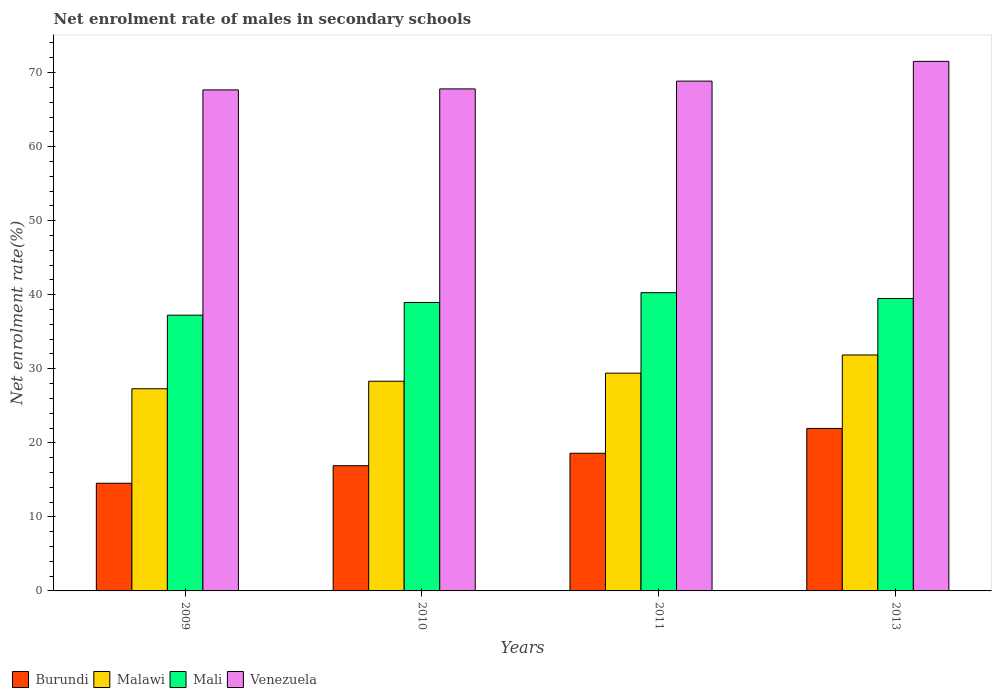How many different coloured bars are there?
Provide a succinct answer. 4. How many groups of bars are there?
Your answer should be very brief. 4. Are the number of bars per tick equal to the number of legend labels?
Keep it short and to the point. Yes. Are the number of bars on each tick of the X-axis equal?
Provide a succinct answer. Yes. How many bars are there on the 4th tick from the left?
Ensure brevity in your answer.  4. How many bars are there on the 2nd tick from the right?
Your answer should be very brief. 4. What is the label of the 3rd group of bars from the left?
Your answer should be very brief. 2011. What is the net enrolment rate of males in secondary schools in Malawi in 2011?
Offer a very short reply. 29.41. Across all years, what is the maximum net enrolment rate of males in secondary schools in Venezuela?
Provide a short and direct response. 71.52. Across all years, what is the minimum net enrolment rate of males in secondary schools in Malawi?
Offer a terse response. 27.3. In which year was the net enrolment rate of males in secondary schools in Burundi maximum?
Your answer should be very brief. 2013. What is the total net enrolment rate of males in secondary schools in Malawi in the graph?
Provide a succinct answer. 116.9. What is the difference between the net enrolment rate of males in secondary schools in Burundi in 2009 and that in 2010?
Your answer should be compact. -2.37. What is the difference between the net enrolment rate of males in secondary schools in Malawi in 2010 and the net enrolment rate of males in secondary schools in Burundi in 2009?
Give a very brief answer. 13.78. What is the average net enrolment rate of males in secondary schools in Malawi per year?
Provide a succinct answer. 29.22. In the year 2011, what is the difference between the net enrolment rate of males in secondary schools in Burundi and net enrolment rate of males in secondary schools in Malawi?
Your answer should be very brief. -10.82. What is the ratio of the net enrolment rate of males in secondary schools in Burundi in 2010 to that in 2013?
Your answer should be compact. 0.77. Is the difference between the net enrolment rate of males in secondary schools in Burundi in 2009 and 2010 greater than the difference between the net enrolment rate of males in secondary schools in Malawi in 2009 and 2010?
Provide a succinct answer. No. What is the difference between the highest and the second highest net enrolment rate of males in secondary schools in Malawi?
Your answer should be compact. 2.46. What is the difference between the highest and the lowest net enrolment rate of males in secondary schools in Malawi?
Your answer should be very brief. 4.56. In how many years, is the net enrolment rate of males in secondary schools in Burundi greater than the average net enrolment rate of males in secondary schools in Burundi taken over all years?
Your response must be concise. 2. Is the sum of the net enrolment rate of males in secondary schools in Venezuela in 2011 and 2013 greater than the maximum net enrolment rate of males in secondary schools in Malawi across all years?
Offer a terse response. Yes. Is it the case that in every year, the sum of the net enrolment rate of males in secondary schools in Mali and net enrolment rate of males in secondary schools in Malawi is greater than the sum of net enrolment rate of males in secondary schools in Venezuela and net enrolment rate of males in secondary schools in Burundi?
Your response must be concise. Yes. What does the 2nd bar from the left in 2009 represents?
Your response must be concise. Malawi. What does the 3rd bar from the right in 2011 represents?
Offer a terse response. Malawi. Is it the case that in every year, the sum of the net enrolment rate of males in secondary schools in Burundi and net enrolment rate of males in secondary schools in Venezuela is greater than the net enrolment rate of males in secondary schools in Malawi?
Ensure brevity in your answer.  Yes. Are all the bars in the graph horizontal?
Make the answer very short. No. How many years are there in the graph?
Keep it short and to the point. 4. Where does the legend appear in the graph?
Provide a succinct answer. Bottom left. How are the legend labels stacked?
Provide a succinct answer. Horizontal. What is the title of the graph?
Make the answer very short. Net enrolment rate of males in secondary schools. What is the label or title of the Y-axis?
Your response must be concise. Net enrolment rate(%). What is the Net enrolment rate(%) of Burundi in 2009?
Keep it short and to the point. 14.54. What is the Net enrolment rate(%) of Malawi in 2009?
Ensure brevity in your answer.  27.3. What is the Net enrolment rate(%) of Mali in 2009?
Ensure brevity in your answer.  37.24. What is the Net enrolment rate(%) in Venezuela in 2009?
Give a very brief answer. 67.66. What is the Net enrolment rate(%) of Burundi in 2010?
Ensure brevity in your answer.  16.91. What is the Net enrolment rate(%) of Malawi in 2010?
Provide a short and direct response. 28.32. What is the Net enrolment rate(%) in Mali in 2010?
Offer a very short reply. 38.95. What is the Net enrolment rate(%) in Venezuela in 2010?
Your answer should be compact. 67.8. What is the Net enrolment rate(%) of Burundi in 2011?
Offer a terse response. 18.59. What is the Net enrolment rate(%) of Malawi in 2011?
Give a very brief answer. 29.41. What is the Net enrolment rate(%) in Mali in 2011?
Your answer should be compact. 40.28. What is the Net enrolment rate(%) in Venezuela in 2011?
Your answer should be very brief. 68.85. What is the Net enrolment rate(%) in Burundi in 2013?
Offer a very short reply. 21.94. What is the Net enrolment rate(%) in Malawi in 2013?
Offer a very short reply. 31.87. What is the Net enrolment rate(%) in Mali in 2013?
Make the answer very short. 39.49. What is the Net enrolment rate(%) of Venezuela in 2013?
Offer a terse response. 71.52. Across all years, what is the maximum Net enrolment rate(%) of Burundi?
Your response must be concise. 21.94. Across all years, what is the maximum Net enrolment rate(%) of Malawi?
Keep it short and to the point. 31.87. Across all years, what is the maximum Net enrolment rate(%) in Mali?
Offer a very short reply. 40.28. Across all years, what is the maximum Net enrolment rate(%) of Venezuela?
Offer a terse response. 71.52. Across all years, what is the minimum Net enrolment rate(%) in Burundi?
Give a very brief answer. 14.54. Across all years, what is the minimum Net enrolment rate(%) of Malawi?
Your answer should be very brief. 27.3. Across all years, what is the minimum Net enrolment rate(%) in Mali?
Ensure brevity in your answer.  37.24. Across all years, what is the minimum Net enrolment rate(%) of Venezuela?
Provide a short and direct response. 67.66. What is the total Net enrolment rate(%) in Burundi in the graph?
Make the answer very short. 71.99. What is the total Net enrolment rate(%) in Malawi in the graph?
Make the answer very short. 116.9. What is the total Net enrolment rate(%) in Mali in the graph?
Provide a short and direct response. 155.96. What is the total Net enrolment rate(%) of Venezuela in the graph?
Your answer should be compact. 275.83. What is the difference between the Net enrolment rate(%) in Burundi in 2009 and that in 2010?
Provide a succinct answer. -2.37. What is the difference between the Net enrolment rate(%) in Malawi in 2009 and that in 2010?
Offer a terse response. -1.01. What is the difference between the Net enrolment rate(%) in Mali in 2009 and that in 2010?
Your answer should be compact. -1.71. What is the difference between the Net enrolment rate(%) in Venezuela in 2009 and that in 2010?
Offer a very short reply. -0.14. What is the difference between the Net enrolment rate(%) of Burundi in 2009 and that in 2011?
Provide a short and direct response. -4.05. What is the difference between the Net enrolment rate(%) of Malawi in 2009 and that in 2011?
Provide a succinct answer. -2.1. What is the difference between the Net enrolment rate(%) of Mali in 2009 and that in 2011?
Ensure brevity in your answer.  -3.04. What is the difference between the Net enrolment rate(%) in Venezuela in 2009 and that in 2011?
Provide a short and direct response. -1.19. What is the difference between the Net enrolment rate(%) of Burundi in 2009 and that in 2013?
Your answer should be very brief. -7.4. What is the difference between the Net enrolment rate(%) of Malawi in 2009 and that in 2013?
Your answer should be very brief. -4.56. What is the difference between the Net enrolment rate(%) in Mali in 2009 and that in 2013?
Give a very brief answer. -2.25. What is the difference between the Net enrolment rate(%) of Venezuela in 2009 and that in 2013?
Ensure brevity in your answer.  -3.86. What is the difference between the Net enrolment rate(%) of Burundi in 2010 and that in 2011?
Your answer should be compact. -1.68. What is the difference between the Net enrolment rate(%) in Malawi in 2010 and that in 2011?
Offer a very short reply. -1.09. What is the difference between the Net enrolment rate(%) of Mali in 2010 and that in 2011?
Provide a short and direct response. -1.33. What is the difference between the Net enrolment rate(%) in Venezuela in 2010 and that in 2011?
Ensure brevity in your answer.  -1.05. What is the difference between the Net enrolment rate(%) in Burundi in 2010 and that in 2013?
Offer a very short reply. -5.03. What is the difference between the Net enrolment rate(%) of Malawi in 2010 and that in 2013?
Your answer should be very brief. -3.55. What is the difference between the Net enrolment rate(%) in Mali in 2010 and that in 2013?
Provide a short and direct response. -0.54. What is the difference between the Net enrolment rate(%) of Venezuela in 2010 and that in 2013?
Your response must be concise. -3.72. What is the difference between the Net enrolment rate(%) in Burundi in 2011 and that in 2013?
Give a very brief answer. -3.35. What is the difference between the Net enrolment rate(%) of Malawi in 2011 and that in 2013?
Offer a terse response. -2.46. What is the difference between the Net enrolment rate(%) of Mali in 2011 and that in 2013?
Your answer should be compact. 0.79. What is the difference between the Net enrolment rate(%) in Venezuela in 2011 and that in 2013?
Give a very brief answer. -2.67. What is the difference between the Net enrolment rate(%) of Burundi in 2009 and the Net enrolment rate(%) of Malawi in 2010?
Keep it short and to the point. -13.78. What is the difference between the Net enrolment rate(%) in Burundi in 2009 and the Net enrolment rate(%) in Mali in 2010?
Make the answer very short. -24.41. What is the difference between the Net enrolment rate(%) of Burundi in 2009 and the Net enrolment rate(%) of Venezuela in 2010?
Keep it short and to the point. -53.26. What is the difference between the Net enrolment rate(%) of Malawi in 2009 and the Net enrolment rate(%) of Mali in 2010?
Ensure brevity in your answer.  -11.65. What is the difference between the Net enrolment rate(%) in Malawi in 2009 and the Net enrolment rate(%) in Venezuela in 2010?
Provide a short and direct response. -40.49. What is the difference between the Net enrolment rate(%) of Mali in 2009 and the Net enrolment rate(%) of Venezuela in 2010?
Offer a very short reply. -30.56. What is the difference between the Net enrolment rate(%) of Burundi in 2009 and the Net enrolment rate(%) of Malawi in 2011?
Ensure brevity in your answer.  -14.86. What is the difference between the Net enrolment rate(%) in Burundi in 2009 and the Net enrolment rate(%) in Mali in 2011?
Offer a very short reply. -25.74. What is the difference between the Net enrolment rate(%) of Burundi in 2009 and the Net enrolment rate(%) of Venezuela in 2011?
Keep it short and to the point. -54.31. What is the difference between the Net enrolment rate(%) in Malawi in 2009 and the Net enrolment rate(%) in Mali in 2011?
Offer a terse response. -12.98. What is the difference between the Net enrolment rate(%) in Malawi in 2009 and the Net enrolment rate(%) in Venezuela in 2011?
Your answer should be very brief. -41.55. What is the difference between the Net enrolment rate(%) of Mali in 2009 and the Net enrolment rate(%) of Venezuela in 2011?
Keep it short and to the point. -31.61. What is the difference between the Net enrolment rate(%) of Burundi in 2009 and the Net enrolment rate(%) of Malawi in 2013?
Ensure brevity in your answer.  -17.32. What is the difference between the Net enrolment rate(%) of Burundi in 2009 and the Net enrolment rate(%) of Mali in 2013?
Provide a short and direct response. -24.95. What is the difference between the Net enrolment rate(%) in Burundi in 2009 and the Net enrolment rate(%) in Venezuela in 2013?
Offer a terse response. -56.98. What is the difference between the Net enrolment rate(%) in Malawi in 2009 and the Net enrolment rate(%) in Mali in 2013?
Keep it short and to the point. -12.19. What is the difference between the Net enrolment rate(%) of Malawi in 2009 and the Net enrolment rate(%) of Venezuela in 2013?
Give a very brief answer. -44.21. What is the difference between the Net enrolment rate(%) of Mali in 2009 and the Net enrolment rate(%) of Venezuela in 2013?
Offer a very short reply. -34.28. What is the difference between the Net enrolment rate(%) of Burundi in 2010 and the Net enrolment rate(%) of Malawi in 2011?
Provide a short and direct response. -12.5. What is the difference between the Net enrolment rate(%) of Burundi in 2010 and the Net enrolment rate(%) of Mali in 2011?
Keep it short and to the point. -23.37. What is the difference between the Net enrolment rate(%) in Burundi in 2010 and the Net enrolment rate(%) in Venezuela in 2011?
Your answer should be very brief. -51.94. What is the difference between the Net enrolment rate(%) of Malawi in 2010 and the Net enrolment rate(%) of Mali in 2011?
Offer a terse response. -11.96. What is the difference between the Net enrolment rate(%) in Malawi in 2010 and the Net enrolment rate(%) in Venezuela in 2011?
Offer a terse response. -40.53. What is the difference between the Net enrolment rate(%) in Mali in 2010 and the Net enrolment rate(%) in Venezuela in 2011?
Your response must be concise. -29.9. What is the difference between the Net enrolment rate(%) in Burundi in 2010 and the Net enrolment rate(%) in Malawi in 2013?
Give a very brief answer. -14.96. What is the difference between the Net enrolment rate(%) of Burundi in 2010 and the Net enrolment rate(%) of Mali in 2013?
Provide a short and direct response. -22.58. What is the difference between the Net enrolment rate(%) of Burundi in 2010 and the Net enrolment rate(%) of Venezuela in 2013?
Your answer should be very brief. -54.61. What is the difference between the Net enrolment rate(%) in Malawi in 2010 and the Net enrolment rate(%) in Mali in 2013?
Your response must be concise. -11.17. What is the difference between the Net enrolment rate(%) in Malawi in 2010 and the Net enrolment rate(%) in Venezuela in 2013?
Keep it short and to the point. -43.2. What is the difference between the Net enrolment rate(%) of Mali in 2010 and the Net enrolment rate(%) of Venezuela in 2013?
Provide a succinct answer. -32.57. What is the difference between the Net enrolment rate(%) in Burundi in 2011 and the Net enrolment rate(%) in Malawi in 2013?
Give a very brief answer. -13.27. What is the difference between the Net enrolment rate(%) in Burundi in 2011 and the Net enrolment rate(%) in Mali in 2013?
Your answer should be compact. -20.9. What is the difference between the Net enrolment rate(%) of Burundi in 2011 and the Net enrolment rate(%) of Venezuela in 2013?
Provide a short and direct response. -52.93. What is the difference between the Net enrolment rate(%) of Malawi in 2011 and the Net enrolment rate(%) of Mali in 2013?
Your answer should be very brief. -10.09. What is the difference between the Net enrolment rate(%) in Malawi in 2011 and the Net enrolment rate(%) in Venezuela in 2013?
Provide a succinct answer. -42.11. What is the difference between the Net enrolment rate(%) in Mali in 2011 and the Net enrolment rate(%) in Venezuela in 2013?
Ensure brevity in your answer.  -31.24. What is the average Net enrolment rate(%) in Burundi per year?
Give a very brief answer. 18. What is the average Net enrolment rate(%) in Malawi per year?
Provide a short and direct response. 29.22. What is the average Net enrolment rate(%) of Mali per year?
Offer a terse response. 38.99. What is the average Net enrolment rate(%) of Venezuela per year?
Give a very brief answer. 68.96. In the year 2009, what is the difference between the Net enrolment rate(%) in Burundi and Net enrolment rate(%) in Malawi?
Your answer should be very brief. -12.76. In the year 2009, what is the difference between the Net enrolment rate(%) in Burundi and Net enrolment rate(%) in Mali?
Offer a terse response. -22.7. In the year 2009, what is the difference between the Net enrolment rate(%) of Burundi and Net enrolment rate(%) of Venezuela?
Your answer should be compact. -53.12. In the year 2009, what is the difference between the Net enrolment rate(%) in Malawi and Net enrolment rate(%) in Mali?
Offer a very short reply. -9.93. In the year 2009, what is the difference between the Net enrolment rate(%) of Malawi and Net enrolment rate(%) of Venezuela?
Give a very brief answer. -40.36. In the year 2009, what is the difference between the Net enrolment rate(%) of Mali and Net enrolment rate(%) of Venezuela?
Give a very brief answer. -30.42. In the year 2010, what is the difference between the Net enrolment rate(%) of Burundi and Net enrolment rate(%) of Malawi?
Offer a very short reply. -11.41. In the year 2010, what is the difference between the Net enrolment rate(%) in Burundi and Net enrolment rate(%) in Mali?
Your response must be concise. -22.04. In the year 2010, what is the difference between the Net enrolment rate(%) in Burundi and Net enrolment rate(%) in Venezuela?
Offer a terse response. -50.89. In the year 2010, what is the difference between the Net enrolment rate(%) of Malawi and Net enrolment rate(%) of Mali?
Provide a short and direct response. -10.63. In the year 2010, what is the difference between the Net enrolment rate(%) of Malawi and Net enrolment rate(%) of Venezuela?
Offer a very short reply. -39.48. In the year 2010, what is the difference between the Net enrolment rate(%) of Mali and Net enrolment rate(%) of Venezuela?
Your response must be concise. -28.85. In the year 2011, what is the difference between the Net enrolment rate(%) in Burundi and Net enrolment rate(%) in Malawi?
Ensure brevity in your answer.  -10.82. In the year 2011, what is the difference between the Net enrolment rate(%) of Burundi and Net enrolment rate(%) of Mali?
Ensure brevity in your answer.  -21.69. In the year 2011, what is the difference between the Net enrolment rate(%) of Burundi and Net enrolment rate(%) of Venezuela?
Keep it short and to the point. -50.26. In the year 2011, what is the difference between the Net enrolment rate(%) in Malawi and Net enrolment rate(%) in Mali?
Keep it short and to the point. -10.87. In the year 2011, what is the difference between the Net enrolment rate(%) of Malawi and Net enrolment rate(%) of Venezuela?
Your answer should be compact. -39.44. In the year 2011, what is the difference between the Net enrolment rate(%) in Mali and Net enrolment rate(%) in Venezuela?
Provide a succinct answer. -28.57. In the year 2013, what is the difference between the Net enrolment rate(%) in Burundi and Net enrolment rate(%) in Malawi?
Your response must be concise. -9.92. In the year 2013, what is the difference between the Net enrolment rate(%) in Burundi and Net enrolment rate(%) in Mali?
Offer a very short reply. -17.55. In the year 2013, what is the difference between the Net enrolment rate(%) in Burundi and Net enrolment rate(%) in Venezuela?
Provide a short and direct response. -49.58. In the year 2013, what is the difference between the Net enrolment rate(%) of Malawi and Net enrolment rate(%) of Mali?
Keep it short and to the point. -7.63. In the year 2013, what is the difference between the Net enrolment rate(%) of Malawi and Net enrolment rate(%) of Venezuela?
Make the answer very short. -39.65. In the year 2013, what is the difference between the Net enrolment rate(%) in Mali and Net enrolment rate(%) in Venezuela?
Provide a succinct answer. -32.03. What is the ratio of the Net enrolment rate(%) of Burundi in 2009 to that in 2010?
Provide a succinct answer. 0.86. What is the ratio of the Net enrolment rate(%) in Malawi in 2009 to that in 2010?
Make the answer very short. 0.96. What is the ratio of the Net enrolment rate(%) in Mali in 2009 to that in 2010?
Your answer should be compact. 0.96. What is the ratio of the Net enrolment rate(%) in Burundi in 2009 to that in 2011?
Make the answer very short. 0.78. What is the ratio of the Net enrolment rate(%) in Malawi in 2009 to that in 2011?
Your answer should be compact. 0.93. What is the ratio of the Net enrolment rate(%) of Mali in 2009 to that in 2011?
Offer a terse response. 0.92. What is the ratio of the Net enrolment rate(%) of Venezuela in 2009 to that in 2011?
Offer a very short reply. 0.98. What is the ratio of the Net enrolment rate(%) of Burundi in 2009 to that in 2013?
Offer a very short reply. 0.66. What is the ratio of the Net enrolment rate(%) in Malawi in 2009 to that in 2013?
Make the answer very short. 0.86. What is the ratio of the Net enrolment rate(%) of Mali in 2009 to that in 2013?
Keep it short and to the point. 0.94. What is the ratio of the Net enrolment rate(%) in Venezuela in 2009 to that in 2013?
Your response must be concise. 0.95. What is the ratio of the Net enrolment rate(%) in Burundi in 2010 to that in 2011?
Ensure brevity in your answer.  0.91. What is the ratio of the Net enrolment rate(%) in Malawi in 2010 to that in 2011?
Offer a very short reply. 0.96. What is the ratio of the Net enrolment rate(%) of Mali in 2010 to that in 2011?
Make the answer very short. 0.97. What is the ratio of the Net enrolment rate(%) of Venezuela in 2010 to that in 2011?
Your answer should be very brief. 0.98. What is the ratio of the Net enrolment rate(%) in Burundi in 2010 to that in 2013?
Provide a short and direct response. 0.77. What is the ratio of the Net enrolment rate(%) of Malawi in 2010 to that in 2013?
Ensure brevity in your answer.  0.89. What is the ratio of the Net enrolment rate(%) of Mali in 2010 to that in 2013?
Your answer should be compact. 0.99. What is the ratio of the Net enrolment rate(%) in Venezuela in 2010 to that in 2013?
Your answer should be very brief. 0.95. What is the ratio of the Net enrolment rate(%) of Burundi in 2011 to that in 2013?
Provide a succinct answer. 0.85. What is the ratio of the Net enrolment rate(%) of Malawi in 2011 to that in 2013?
Keep it short and to the point. 0.92. What is the ratio of the Net enrolment rate(%) in Mali in 2011 to that in 2013?
Your response must be concise. 1.02. What is the ratio of the Net enrolment rate(%) of Venezuela in 2011 to that in 2013?
Make the answer very short. 0.96. What is the difference between the highest and the second highest Net enrolment rate(%) of Burundi?
Your response must be concise. 3.35. What is the difference between the highest and the second highest Net enrolment rate(%) of Malawi?
Your answer should be very brief. 2.46. What is the difference between the highest and the second highest Net enrolment rate(%) of Mali?
Offer a very short reply. 0.79. What is the difference between the highest and the second highest Net enrolment rate(%) of Venezuela?
Keep it short and to the point. 2.67. What is the difference between the highest and the lowest Net enrolment rate(%) in Burundi?
Your answer should be compact. 7.4. What is the difference between the highest and the lowest Net enrolment rate(%) in Malawi?
Give a very brief answer. 4.56. What is the difference between the highest and the lowest Net enrolment rate(%) in Mali?
Provide a succinct answer. 3.04. What is the difference between the highest and the lowest Net enrolment rate(%) of Venezuela?
Your response must be concise. 3.86. 